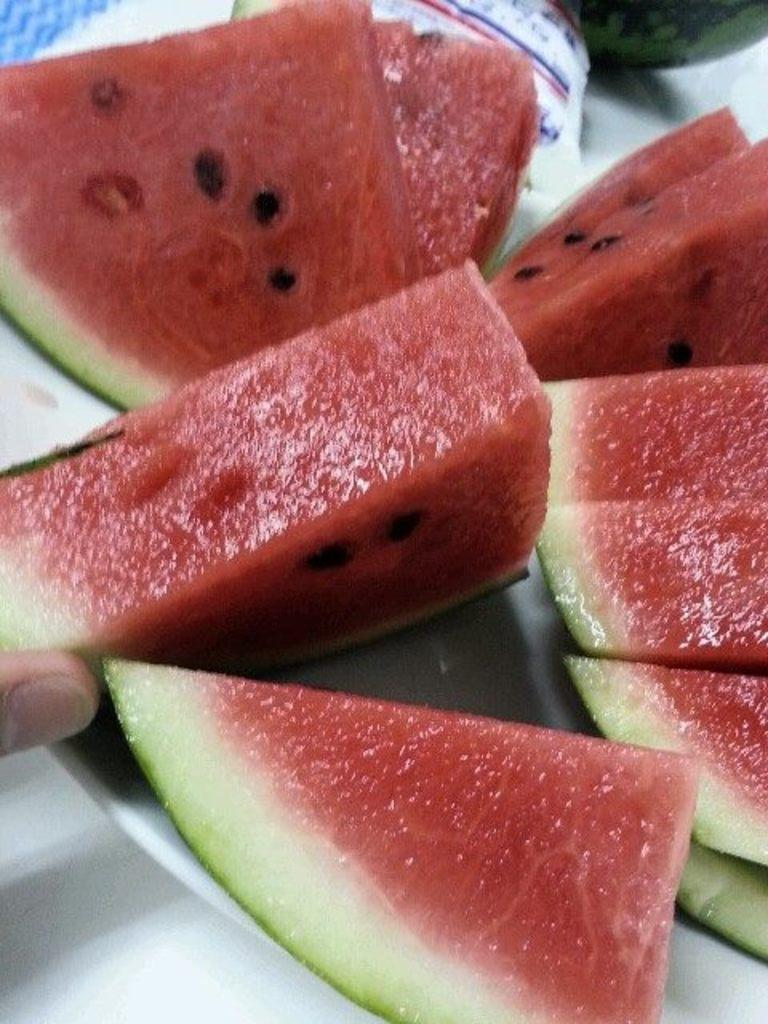What is on the plate that is visible in the image? There is a plate with fruits in the image. Can you describe any other elements in the image besides the plate of fruits? Yes, there is a finger of a person visible in the image. Are there any ants crawling on the plate of fruits in the image? There is no indication of ants in the image; only the plate of fruits and a finger are visible. What type of comfort can be seen in the image? There is no reference to comfort in the image; it features a plate of fruits and a finger. 